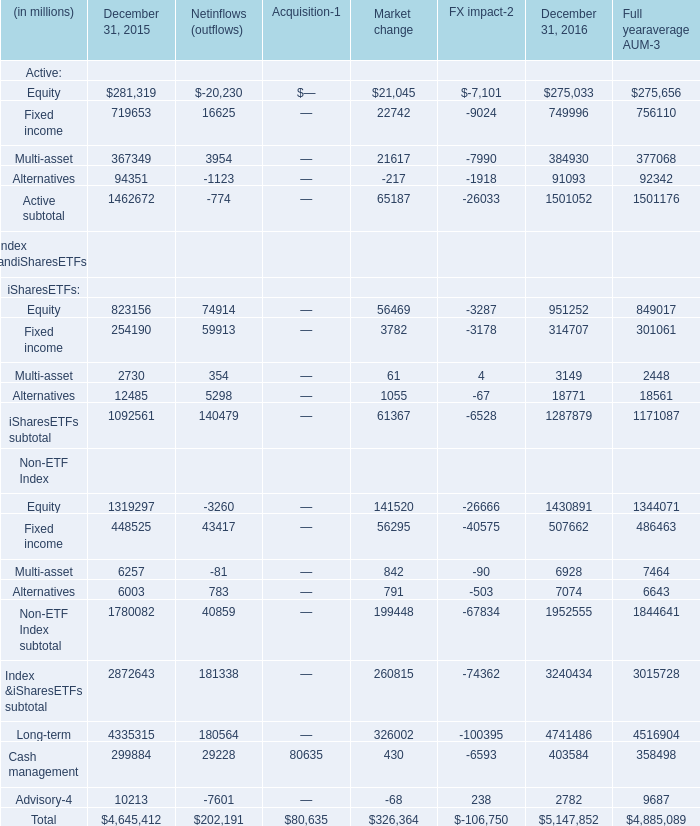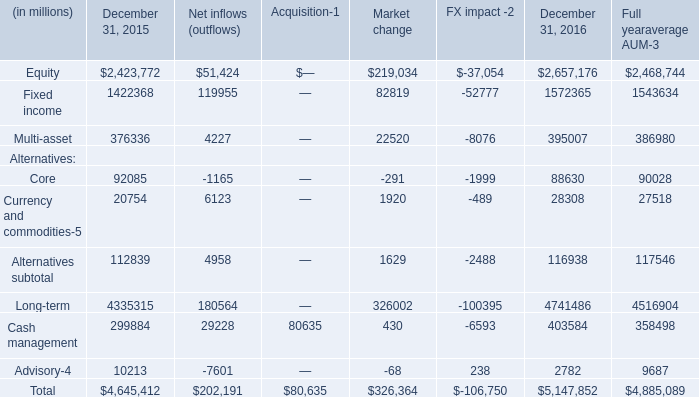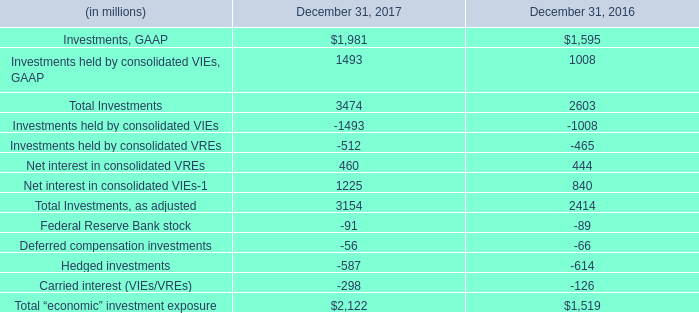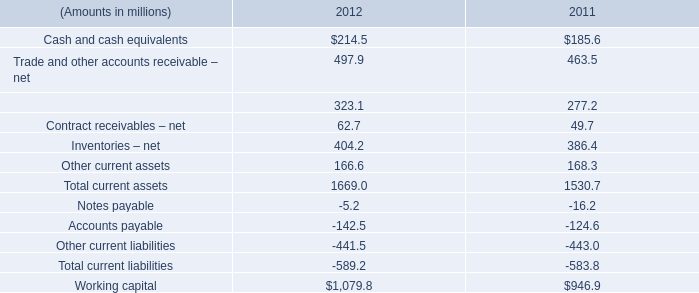what portion of cash and cash equivalents as of 2012 was held outside unites states? 
Computations: (81.4 / 214.5)
Answer: 0.37949. 